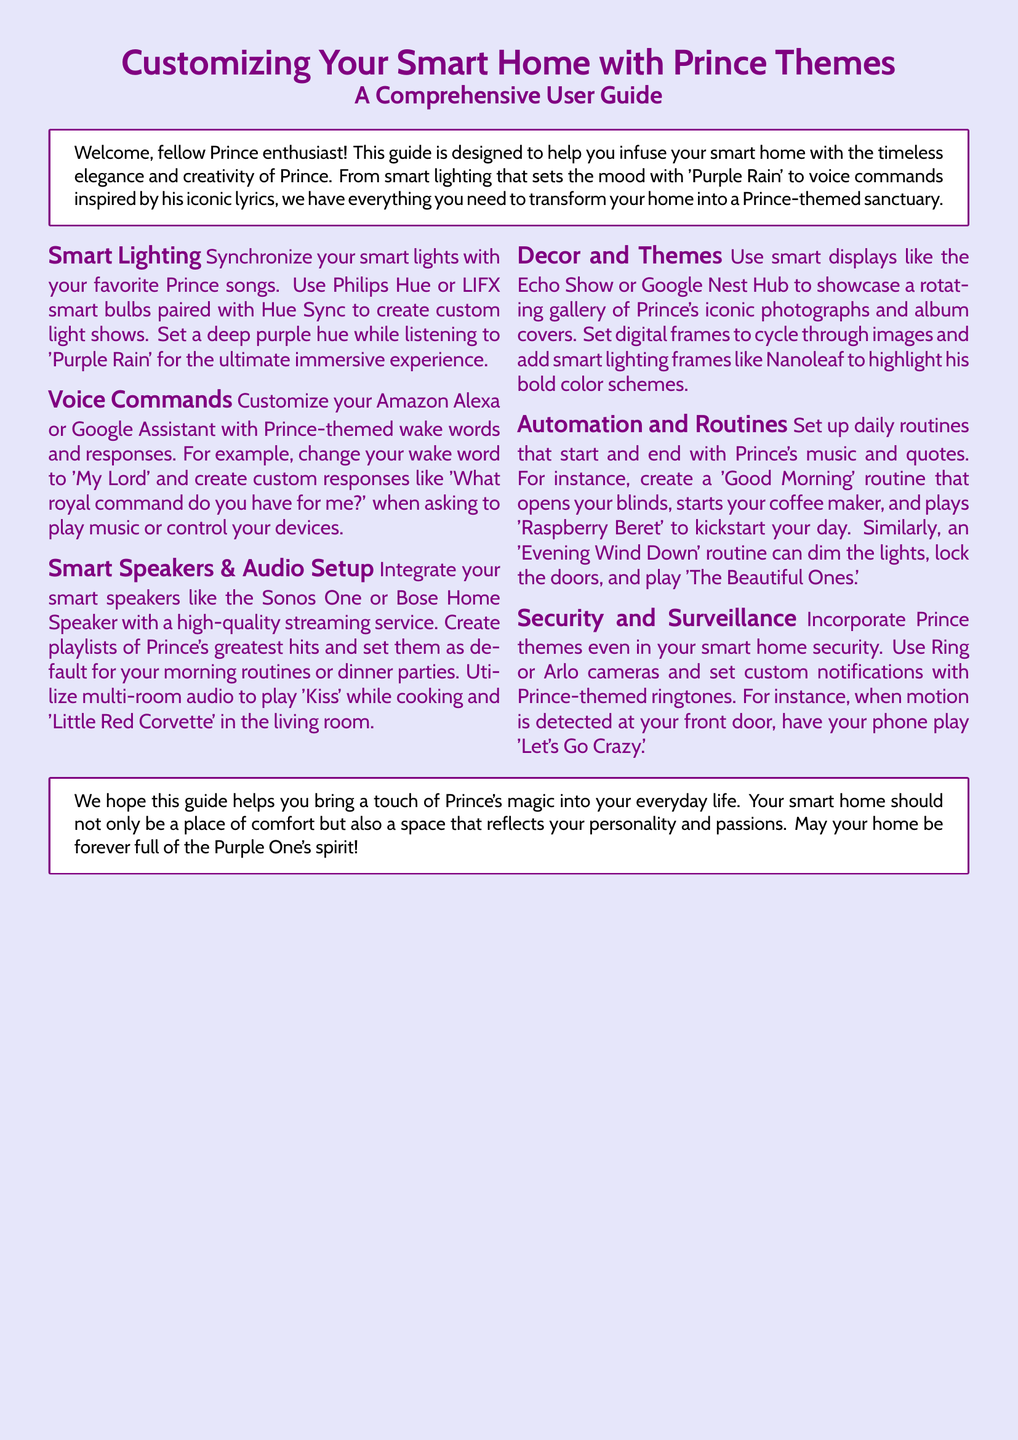What is the main theme of the user guide? The user guide is focused on customizing smart homes with elements inspired by Prince.
Answer: Prince themes Which smart lighting brands are mentioned? The document lists Philips Hue and LIFX as brands for smart lighting.
Answer: Philips Hue and LIFX What custom wake word can be used for voice commands? The guide suggests changing your wake word to 'My Lord.'
Answer: My Lord Which Prince song is recommended for a morning routine? The document suggests playing 'Raspberry Beret' to start your day.
Answer: Raspberry Beret What device can showcase Prince's photographs? The Echo Show or Google Nest Hub can be used to display images.
Answer: Echo Show or Google Nest Hub How can Prince themes be incorporated into security setups? The guide mentions using custom notifications with Prince-themed ringtones for cameras.
Answer: Custom notifications with ringtones What is suggested for creating immersive light shows? Pairing smart bulbs with Hue Sync is advised for immersive experiences.
Answer: Hue Sync Which Prince song should play during an evening wind-down routine? The recommendation is to play 'The Beautiful Ones' during this routine.
Answer: The Beautiful Ones 